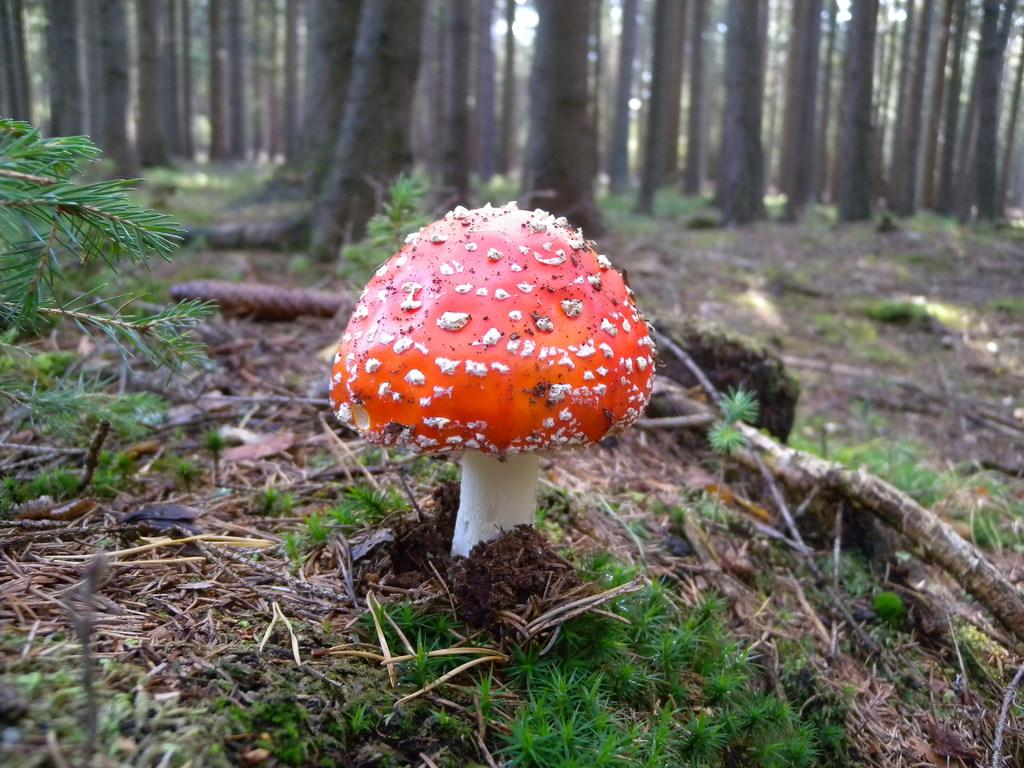What type of mushroom is present in the image? There is a red and white color mushroom in the image. What is the ground covered with in the image? There is grass on the ground in the image. What can be seen in the background of the image? There are trees in the background of the image. How many boys are sitting at the table in the image? There is no table or boys present in the image. The image features a red and white color mushroom, grass on the ground, and trees in the background. 